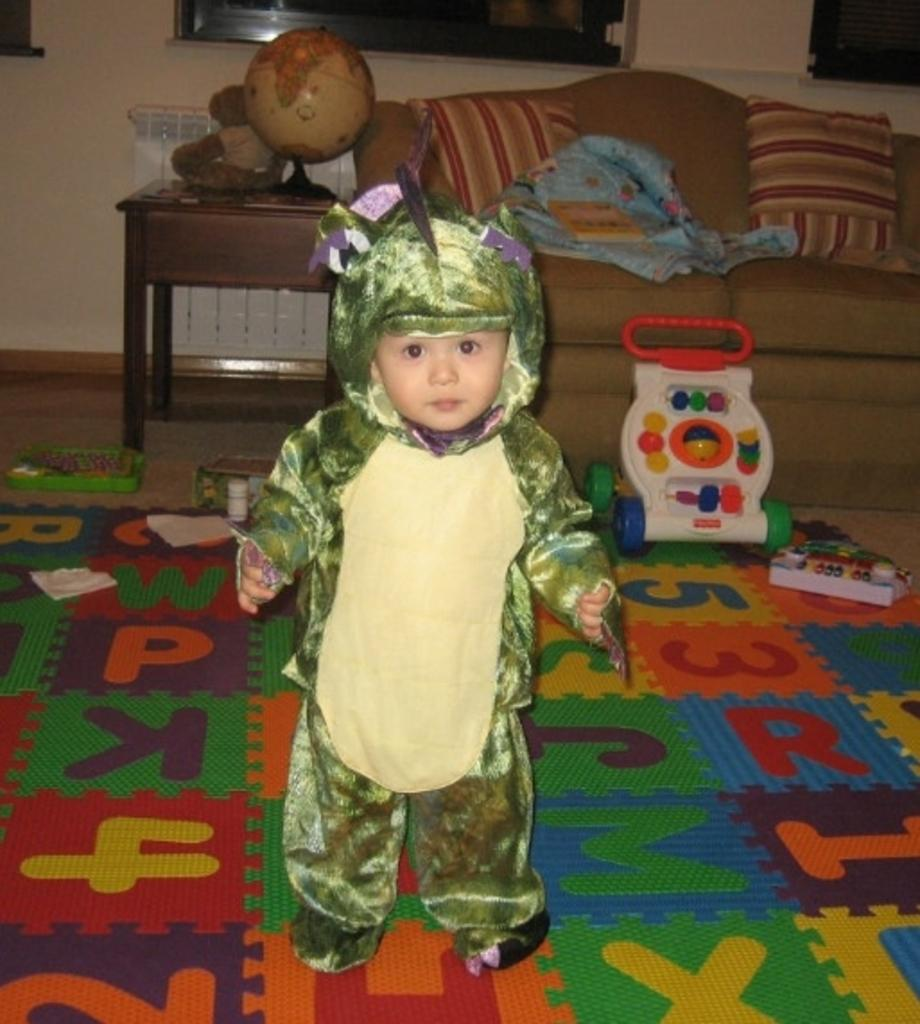What is the main subject of the image? There is a boy standing in the image. What else can be seen in the image besides the boy? There are toys visible in the image, as well as a couch and a globe on a table. What type of meat is being cooked on the stove in the image? There is no stove or meat present in the image. How many tomatoes are on the windowsill in the image? There is no windowsill or tomatoes present in the image. 